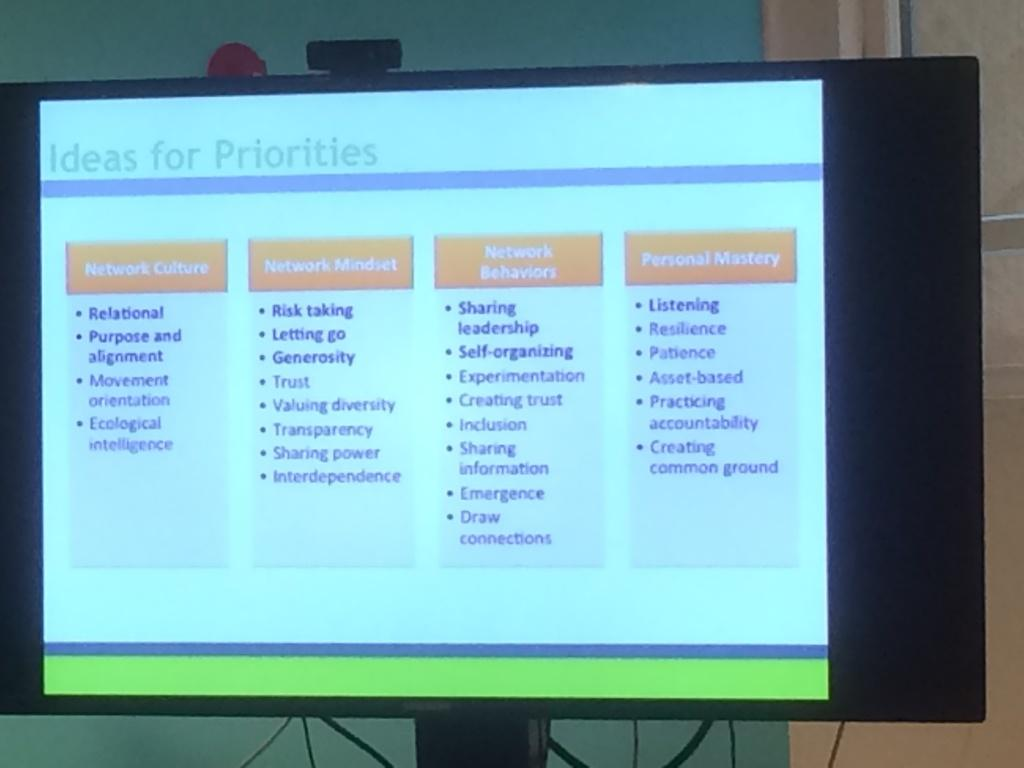Provide a one-sentence caption for the provided image. A computer monitor dispays ideas for priorities on screen. 